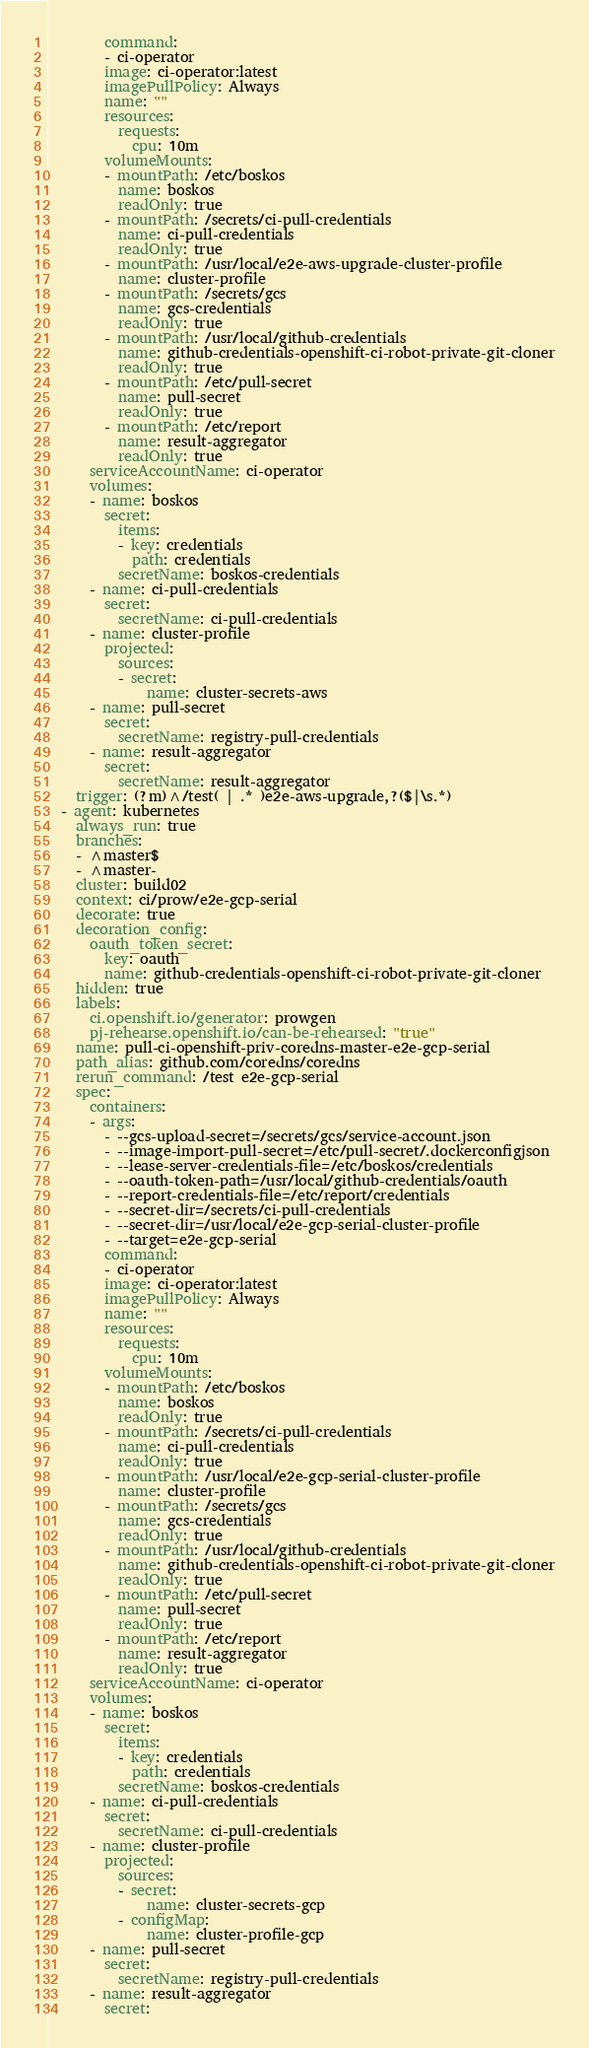<code> <loc_0><loc_0><loc_500><loc_500><_YAML_>        command:
        - ci-operator
        image: ci-operator:latest
        imagePullPolicy: Always
        name: ""
        resources:
          requests:
            cpu: 10m
        volumeMounts:
        - mountPath: /etc/boskos
          name: boskos
          readOnly: true
        - mountPath: /secrets/ci-pull-credentials
          name: ci-pull-credentials
          readOnly: true
        - mountPath: /usr/local/e2e-aws-upgrade-cluster-profile
          name: cluster-profile
        - mountPath: /secrets/gcs
          name: gcs-credentials
          readOnly: true
        - mountPath: /usr/local/github-credentials
          name: github-credentials-openshift-ci-robot-private-git-cloner
          readOnly: true
        - mountPath: /etc/pull-secret
          name: pull-secret
          readOnly: true
        - mountPath: /etc/report
          name: result-aggregator
          readOnly: true
      serviceAccountName: ci-operator
      volumes:
      - name: boskos
        secret:
          items:
          - key: credentials
            path: credentials
          secretName: boskos-credentials
      - name: ci-pull-credentials
        secret:
          secretName: ci-pull-credentials
      - name: cluster-profile
        projected:
          sources:
          - secret:
              name: cluster-secrets-aws
      - name: pull-secret
        secret:
          secretName: registry-pull-credentials
      - name: result-aggregator
        secret:
          secretName: result-aggregator
    trigger: (?m)^/test( | .* )e2e-aws-upgrade,?($|\s.*)
  - agent: kubernetes
    always_run: true
    branches:
    - ^master$
    - ^master-
    cluster: build02
    context: ci/prow/e2e-gcp-serial
    decorate: true
    decoration_config:
      oauth_token_secret:
        key: oauth
        name: github-credentials-openshift-ci-robot-private-git-cloner
    hidden: true
    labels:
      ci.openshift.io/generator: prowgen
      pj-rehearse.openshift.io/can-be-rehearsed: "true"
    name: pull-ci-openshift-priv-coredns-master-e2e-gcp-serial
    path_alias: github.com/coredns/coredns
    rerun_command: /test e2e-gcp-serial
    spec:
      containers:
      - args:
        - --gcs-upload-secret=/secrets/gcs/service-account.json
        - --image-import-pull-secret=/etc/pull-secret/.dockerconfigjson
        - --lease-server-credentials-file=/etc/boskos/credentials
        - --oauth-token-path=/usr/local/github-credentials/oauth
        - --report-credentials-file=/etc/report/credentials
        - --secret-dir=/secrets/ci-pull-credentials
        - --secret-dir=/usr/local/e2e-gcp-serial-cluster-profile
        - --target=e2e-gcp-serial
        command:
        - ci-operator
        image: ci-operator:latest
        imagePullPolicy: Always
        name: ""
        resources:
          requests:
            cpu: 10m
        volumeMounts:
        - mountPath: /etc/boskos
          name: boskos
          readOnly: true
        - mountPath: /secrets/ci-pull-credentials
          name: ci-pull-credentials
          readOnly: true
        - mountPath: /usr/local/e2e-gcp-serial-cluster-profile
          name: cluster-profile
        - mountPath: /secrets/gcs
          name: gcs-credentials
          readOnly: true
        - mountPath: /usr/local/github-credentials
          name: github-credentials-openshift-ci-robot-private-git-cloner
          readOnly: true
        - mountPath: /etc/pull-secret
          name: pull-secret
          readOnly: true
        - mountPath: /etc/report
          name: result-aggregator
          readOnly: true
      serviceAccountName: ci-operator
      volumes:
      - name: boskos
        secret:
          items:
          - key: credentials
            path: credentials
          secretName: boskos-credentials
      - name: ci-pull-credentials
        secret:
          secretName: ci-pull-credentials
      - name: cluster-profile
        projected:
          sources:
          - secret:
              name: cluster-secrets-gcp
          - configMap:
              name: cluster-profile-gcp
      - name: pull-secret
        secret:
          secretName: registry-pull-credentials
      - name: result-aggregator
        secret:</code> 